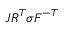Convert formula to latex. <formula><loc_0><loc_0><loc_500><loc_500>J { R } ^ { T } { \sigma } { F } ^ { - T }</formula> 